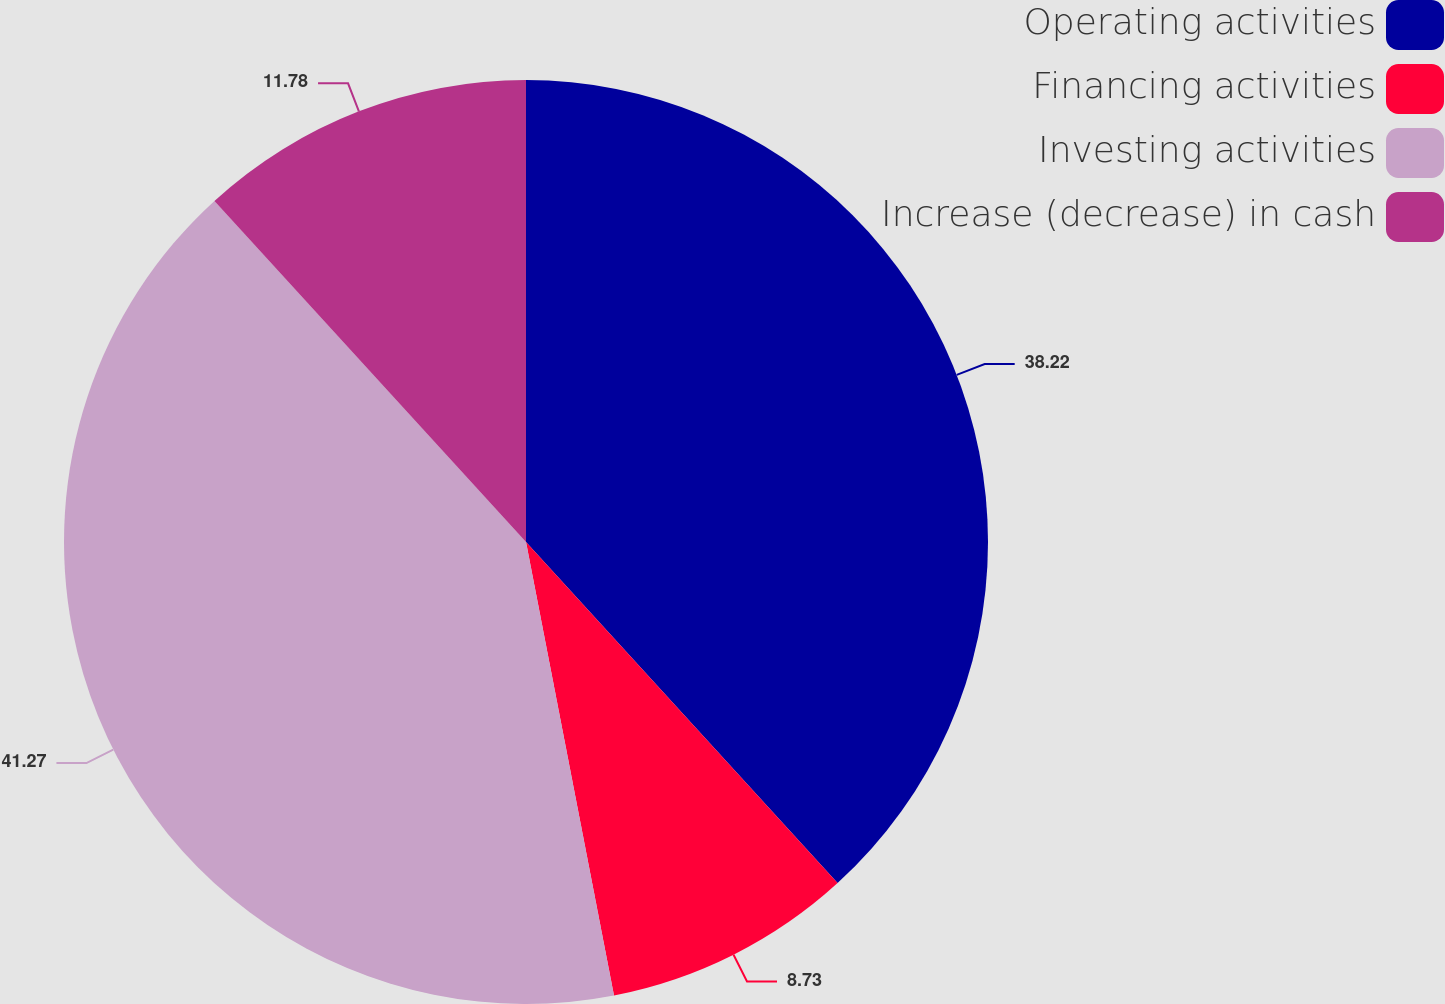Convert chart to OTSL. <chart><loc_0><loc_0><loc_500><loc_500><pie_chart><fcel>Operating activities<fcel>Financing activities<fcel>Investing activities<fcel>Increase (decrease) in cash<nl><fcel>38.22%<fcel>8.73%<fcel>41.27%<fcel>11.78%<nl></chart> 